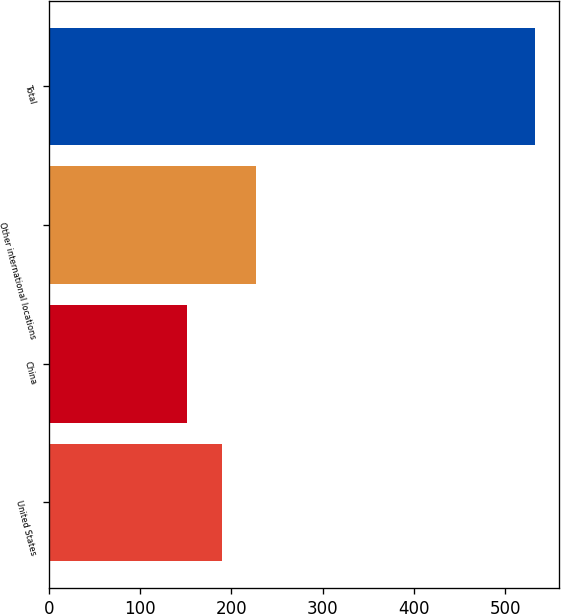Convert chart to OTSL. <chart><loc_0><loc_0><loc_500><loc_500><bar_chart><fcel>United States<fcel>China<fcel>Other international locations<fcel>Total<nl><fcel>189.32<fcel>151.2<fcel>227.44<fcel>532.4<nl></chart> 